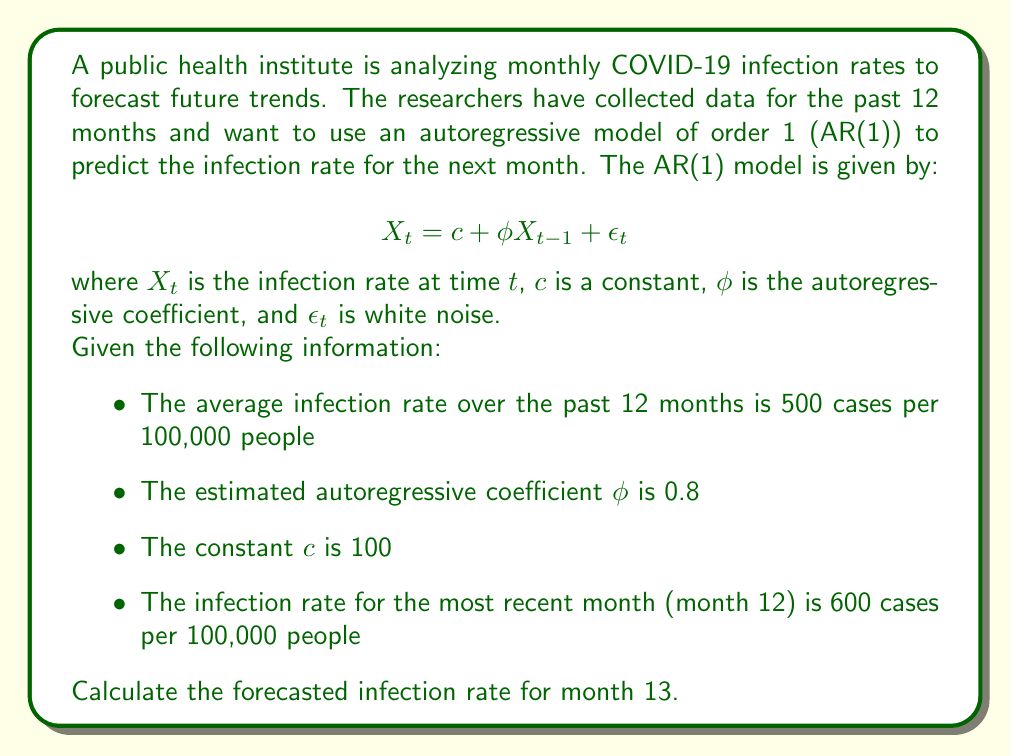Can you answer this question? To solve this problem, we'll use the AR(1) model equation and the given information:

1. Recall the AR(1) model equation:
   $$X_t = c + \phi X_{t-1} + \epsilon_t$$

2. We're forecasting for month 13, so $t = 13$ in our equation:
   $$X_{13} = c + \phi X_{12} + \epsilon_{13}$$

3. We're given the following values:
   - $c = 100$
   - $\phi = 0.8$
   - $X_{12} = 600$

4. For forecasting, we assume the expected value of the error term $\epsilon_{13}$ is zero:
   $E(\epsilon_{13}) = 0$

5. Substituting these values into our equation:
   $$X_{13} = 100 + 0.8(600) + 0$$

6. Now we can calculate:
   $$X_{13} = 100 + 480 = 580$$

Therefore, the forecasted infection rate for month 13 is 580 cases per 100,000 people.

Note: The average infection rate over the past 12 months (500 cases per 100,000 people) wasn't needed for this calculation but could be useful for contextualizing the forecast or for more complex models.
Answer: 580 cases per 100,000 people 